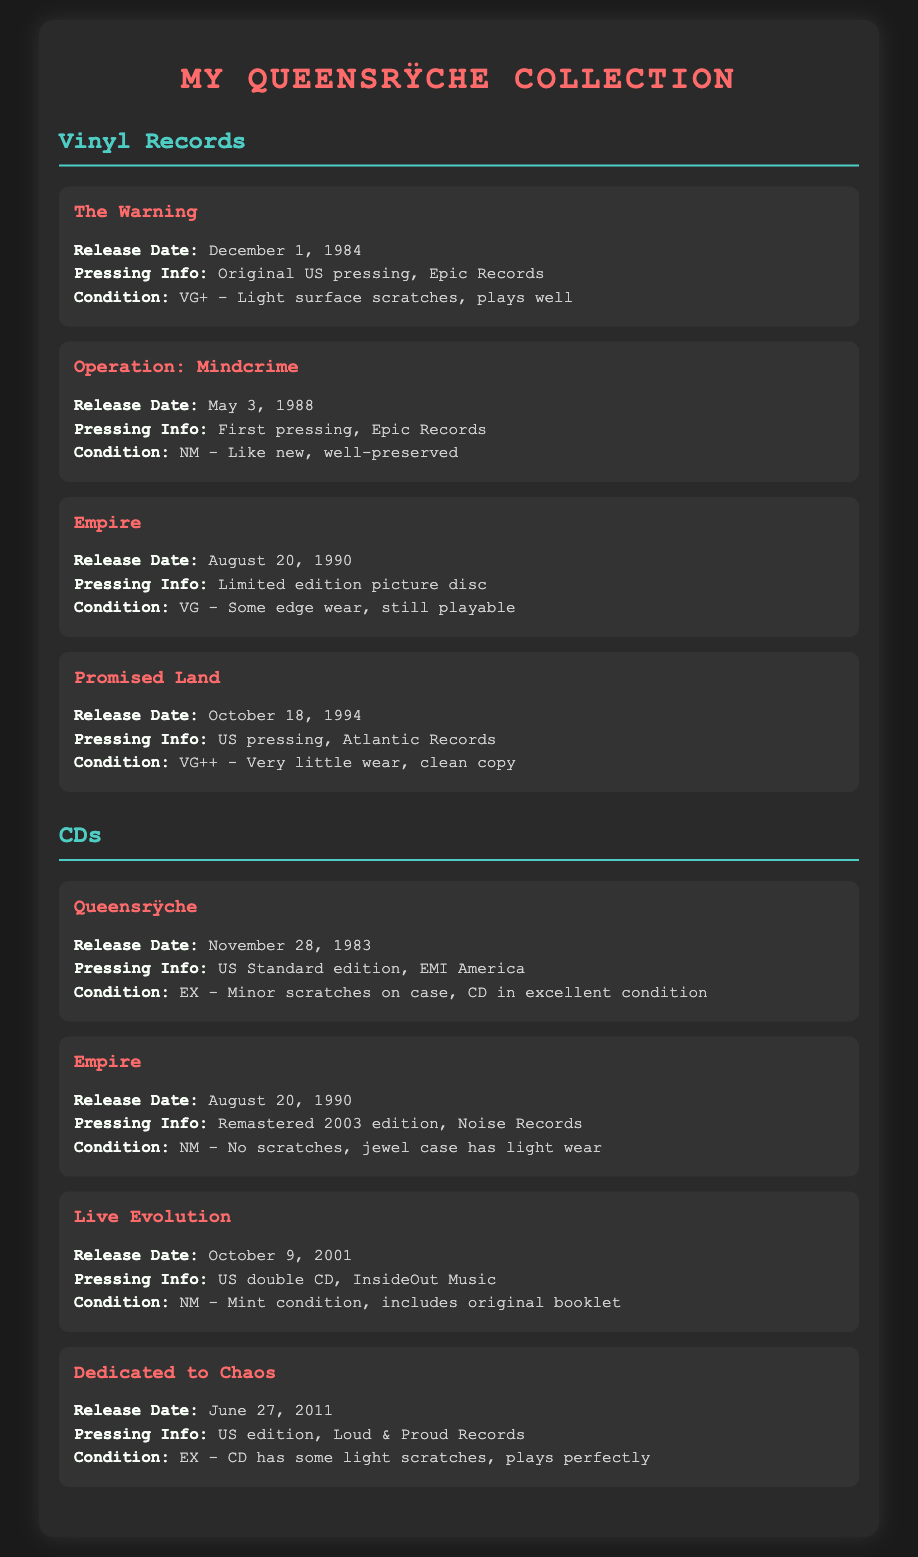What is the release date of Operation: Mindcrime? The release date of Operation: Mindcrime is specifically mentioned within the document as May 3, 1988.
Answer: May 3, 1988 What is the condition of The Warning vinyl? The document states that The Warning vinyl is in condition VG+ - Light surface scratches, plays well.
Answer: VG+ How many vinyl records are listed in the document? The document lists a total of four vinyl records under the Vinyl Records section.
Answer: 4 What is the pressing info for the album Empire (vinyl)? The pressing info for the album Empire is noted as Limited edition picture disc.
Answer: Limited edition picture disc Which album has a release date of October 9, 2001? The document indicates that the album released on October 9, 2001 is Live Evolution.
Answer: Live Evolution What is the condition of the Dedicated to Chaos CD? The document specifies that the condition of the Dedicated to Chaos CD is EX - CD has some light scratches, plays perfectly.
Answer: EX What type of release is the original pressing of the self-titled Queensrÿche album? The pressing information states that it is a US Standard edition.
Answer: US Standard edition Which vinyl record is described as having very little wear? The document notes that the vinyl record Promised Land has very little wear and is labeled as VG++.
Answer: Promised Land What color is used for the album titles in the document? The document shows that the album titles are presented in the color #ff6b6b.
Answer: #ff6b6b 